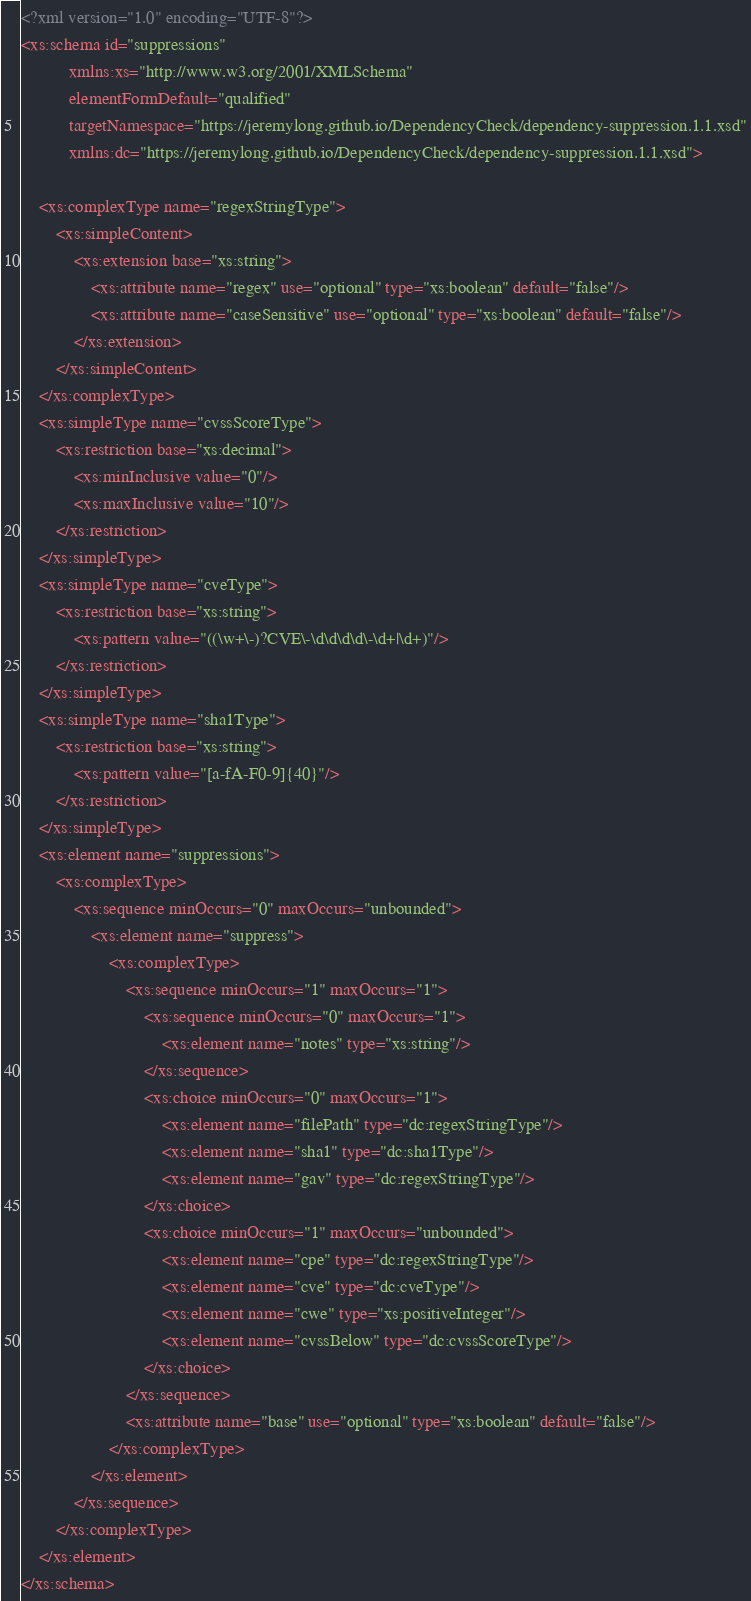<code> <loc_0><loc_0><loc_500><loc_500><_XML_><?xml version="1.0" encoding="UTF-8"?>
<xs:schema id="suppressions"
           xmlns:xs="http://www.w3.org/2001/XMLSchema"
           elementFormDefault="qualified"
           targetNamespace="https://jeremylong.github.io/DependencyCheck/dependency-suppression.1.1.xsd"
           xmlns:dc="https://jeremylong.github.io/DependencyCheck/dependency-suppression.1.1.xsd">

    <xs:complexType name="regexStringType">
        <xs:simpleContent>
            <xs:extension base="xs:string">
                <xs:attribute name="regex" use="optional" type="xs:boolean" default="false"/>
                <xs:attribute name="caseSensitive" use="optional" type="xs:boolean" default="false"/>
            </xs:extension>
        </xs:simpleContent>
    </xs:complexType>
    <xs:simpleType name="cvssScoreType">
        <xs:restriction base="xs:decimal">
            <xs:minInclusive value="0"/>
            <xs:maxInclusive value="10"/>
        </xs:restriction>
    </xs:simpleType>
    <xs:simpleType name="cveType">
        <xs:restriction base="xs:string">
            <xs:pattern value="((\w+\-)?CVE\-\d\d\d\d\-\d+|\d+)"/>
        </xs:restriction>
    </xs:simpleType>
    <xs:simpleType name="sha1Type">
        <xs:restriction base="xs:string">
            <xs:pattern value="[a-fA-F0-9]{40}"/>
        </xs:restriction>
    </xs:simpleType>
    <xs:element name="suppressions">
        <xs:complexType>
            <xs:sequence minOccurs="0" maxOccurs="unbounded">
                <xs:element name="suppress">
                    <xs:complexType>
                        <xs:sequence minOccurs="1" maxOccurs="1">
                            <xs:sequence minOccurs="0" maxOccurs="1">
                                <xs:element name="notes" type="xs:string"/>
                            </xs:sequence>
                            <xs:choice minOccurs="0" maxOccurs="1">
                                <xs:element name="filePath" type="dc:regexStringType"/>
                                <xs:element name="sha1" type="dc:sha1Type"/>
                                <xs:element name="gav" type="dc:regexStringType"/>
                            </xs:choice>
                            <xs:choice minOccurs="1" maxOccurs="unbounded">
                                <xs:element name="cpe" type="dc:regexStringType"/>
                                <xs:element name="cve" type="dc:cveType"/>
                                <xs:element name="cwe" type="xs:positiveInteger"/>
                                <xs:element name="cvssBelow" type="dc:cvssScoreType"/>
                            </xs:choice>
                        </xs:sequence>
                        <xs:attribute name="base" use="optional" type="xs:boolean" default="false"/>
                    </xs:complexType>
                </xs:element>
            </xs:sequence>
        </xs:complexType>
    </xs:element>
</xs:schema>
</code> 